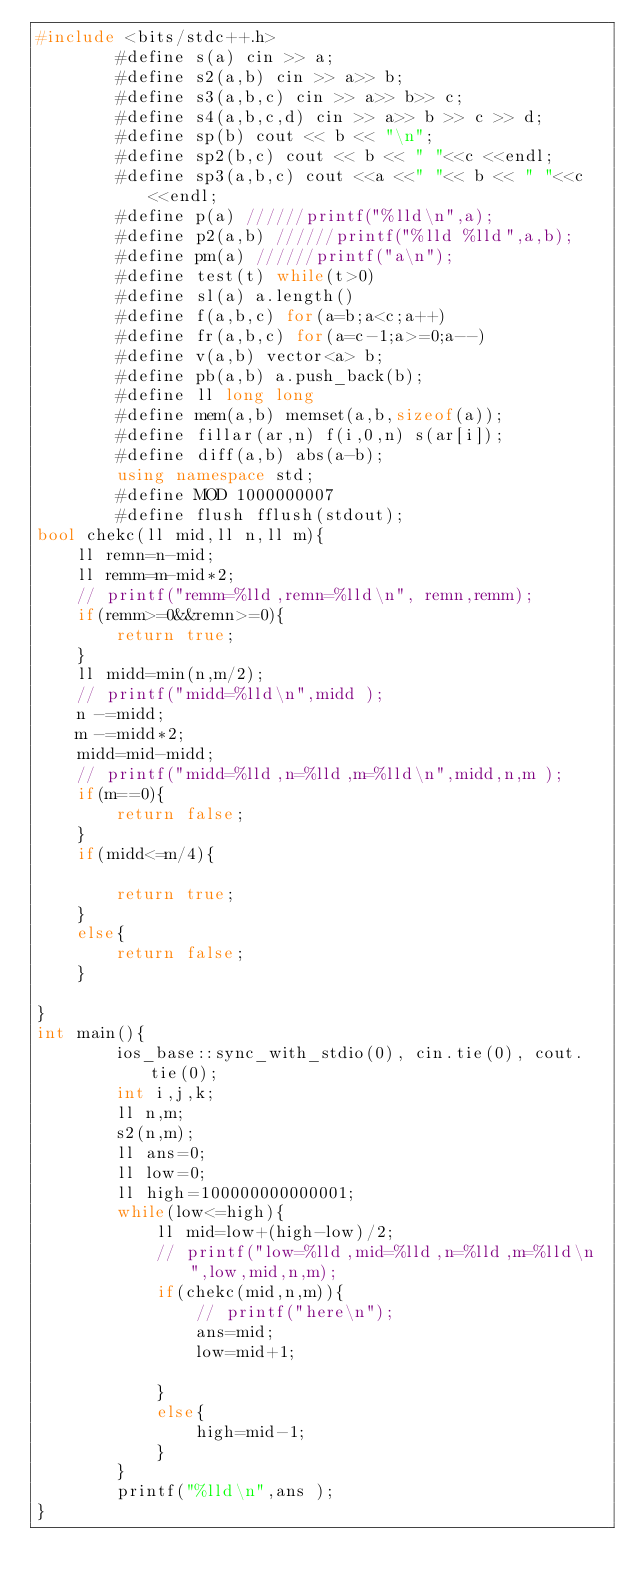<code> <loc_0><loc_0><loc_500><loc_500><_C++_>#include <bits/stdc++.h>
        #define s(a) cin >> a;
        #define s2(a,b) cin >> a>> b;
        #define s3(a,b,c) cin >> a>> b>> c;
        #define s4(a,b,c,d) cin >> a>> b >> c >> d;
        #define sp(b) cout << b << "\n";
        #define sp2(b,c) cout << b << " "<<c <<endl; 
        #define sp3(a,b,c) cout <<a <<" "<< b << " "<<c <<endl; 
        #define p(a) //////printf("%lld\n",a);
        #define p2(a,b) //////printf("%lld %lld",a,b);
        #define pm(a) //////printf("a\n");
        #define test(t) while(t>0)
        #define sl(a) a.length()
        #define f(a,b,c) for(a=b;a<c;a++)
        #define fr(a,b,c) for(a=c-1;a>=0;a--)
        #define v(a,b) vector<a> b;
        #define pb(a,b) a.push_back(b);
        #define ll long long
        #define mem(a,b) memset(a,b,sizeof(a));
        #define fillar(ar,n) f(i,0,n) s(ar[i]);
        #define diff(a,b) abs(a-b);
        using namespace std;
        #define MOD 1000000007
        #define flush fflush(stdout);
bool chekc(ll mid,ll n,ll m){
    ll remn=n-mid;
    ll remm=m-mid*2;
    // printf("remm=%lld,remn=%lld\n", remn,remm);
    if(remm>=0&&remn>=0){
        return true;
    }
    ll midd=min(n,m/2);
    // printf("midd=%lld\n",midd );
    n -=midd;
    m -=midd*2;
    midd=mid-midd;
    // printf("midd=%lld,n=%lld,m=%lld\n",midd,n,m );
    if(m==0){
        return false;
    }
    if(midd<=m/4){

        return true;
    }
    else{
        return false;
    }

}
int main(){
        ios_base::sync_with_stdio(0), cin.tie(0), cout.tie(0);
        int i,j,k;
        ll n,m;
        s2(n,m);
        ll ans=0;
        ll low=0;
        ll high=100000000000001;
        while(low<=high){
            ll mid=low+(high-low)/2;
            // printf("low=%lld,mid=%lld,n=%lld,m=%lld\n",low,mid,n,m);
            if(chekc(mid,n,m)){
                // printf("here\n");
                ans=mid;
                low=mid+1;

            }
            else{
                high=mid-1;
            }
        }
        printf("%lld\n",ans );
}

          </code> 